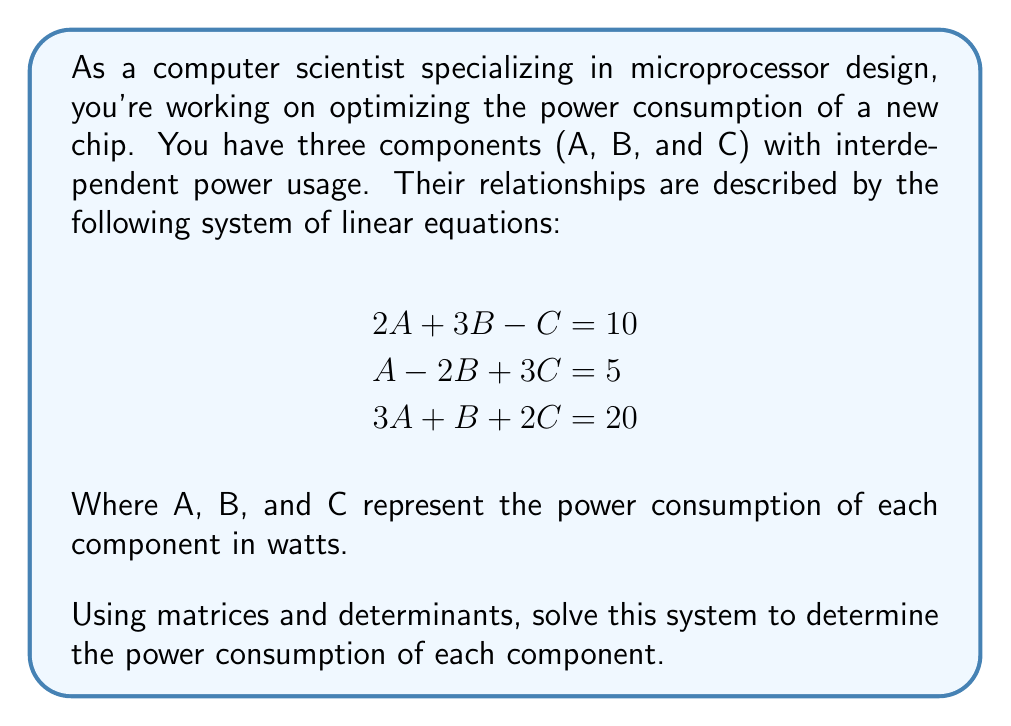Can you answer this question? To solve this system using matrices and determinants, we'll follow these steps:

1) First, let's express the system in matrix form:

   $$\begin{bmatrix}
   2 & 3 & -1 \\
   1 & -2 & 3 \\
   3 & 1 & 2
   \end{bmatrix}
   \begin{bmatrix}
   A \\
   B \\
   C
   \end{bmatrix} =
   \begin{bmatrix}
   10 \\
   5 \\
   20
   \end{bmatrix}$$

2) We'll use Cramer's rule to solve this system. Let's call our coefficient matrix A:

   $$A = \begin{bmatrix}
   2 & 3 & -1 \\
   1 & -2 & 3 \\
   3 & 1 & 2
   \end{bmatrix}$$

3) Calculate the determinant of A:

   $$\det(A) = 2(-2(2) - 3(1)) - 3(1(2) - 3(3)) + (-1)(1(1) - 3(-2))$$
   $$\det(A) = 2(-4 - 3) - 3(2 - 9) + (-1)(1 + 6)$$
   $$\det(A) = 2(-7) - 3(-7) + (-7) = -14 + 21 - 7 = 0$$

4) Now, let's create matrices for each variable by replacing the corresponding column with the constant terms:

   $$A_A = \begin{bmatrix}
   10 & 3 & -1 \\
   5 & -2 & 3 \\
   20 & 1 & 2
   \end{bmatrix}, 
   A_B = \begin{bmatrix}
   2 & 10 & -1 \\
   1 & 5 & 3 \\
   3 & 20 & 2
   \end{bmatrix},
   A_C = \begin{bmatrix}
   2 & 3 & 10 \\
   1 & -2 & 5 \\
   3 & 1 & 20
   \end{bmatrix}$$

5) Calculate the determinants:

   $$\det(A_A) = 10(-2(2) - 3(1)) - 3(5(2) - 20(3)) + (-1)(5(1) - 20(-2))$$
   $$\det(A_A) = 10(-4 - 3) - 3(10 - 60) + (-1)(5 + 40) = -70 + 150 - 45 = 35$$

   $$\det(A_B) = 2(5(2) - 20(3)) - 10(1(2) - 3(3)) + (-1)(1(20) - 3(5))$$
   $$\det(A_B) = 2(10 - 60) - 10(2 - 9) + (-1)(20 - 15) = -100 + 70 - 5 = -35$$

   $$\det(A_C) = 2(-2(20) - 5(1)) - 3(1(20) - 5(3)) + 10(1(1) - 5(-2))$$
   $$\det(A_C) = 2(-40 - 5) - 3(20 - 15) + 10(1 + 10) = -90 - 15 + 110 = 5$$

6) Using Cramer's rule, we can now calculate A, B, and C:

   $$A = \frac{\det(A_A)}{\det(A)} = \frac{35}{0} \text{ (undefined)}$$
   $$B = \frac{\det(A_B)}{\det(A)} = \frac{-35}{0} \text{ (undefined)}$$
   $$C = \frac{\det(A_C)}{\det(A)} = \frac{5}{0} \text{ (undefined)}$$

7) Since we're dividing by zero, this system has either no solution or infinitely many solutions. To determine which, we'll check if the augmented matrix is consistent:

   $$\begin{bmatrix}
   2 & 3 & -1 & 10 \\
   1 & -2 & 3 & 5 \\
   3 & 1 & 2 & 20
   \end{bmatrix}$$

   Performing row operations:

   $$\begin{bmatrix}
   2 & 3 & -1 & 10 \\
   0 & -\frac{7}{2} & \frac{7}{2} & 0 \\
   0 & -\frac{5}{2} & \frac{5}{2} & 0
   \end{bmatrix}$$

   The last two rows are linearly dependent, and their constants are both 0, indicating that this system has infinitely many solutions.
Answer: The system has infinitely many solutions. This means there are infinitely many combinations of power consumptions for components A, B, and C that satisfy the given equations. In practical terms, this suggests that the power relationships between these components are not uniquely constrained, allowing for flexibility in power allocation while maintaining the overall system requirements. 